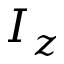<formula> <loc_0><loc_0><loc_500><loc_500>I _ { z }</formula> 